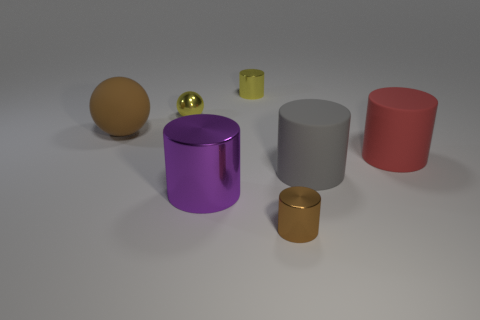Subtract all gray cylinders. How many cylinders are left? 4 Subtract all yellow metal cylinders. How many cylinders are left? 4 Add 3 small brown objects. How many objects exist? 10 Subtract all cylinders. How many objects are left? 2 Subtract 0 purple cubes. How many objects are left? 7 Subtract 4 cylinders. How many cylinders are left? 1 Subtract all cyan cylinders. Subtract all gray cubes. How many cylinders are left? 5 Subtract all red blocks. How many cyan cylinders are left? 0 Subtract all tiny gray metal balls. Subtract all purple shiny objects. How many objects are left? 6 Add 3 yellow cylinders. How many yellow cylinders are left? 4 